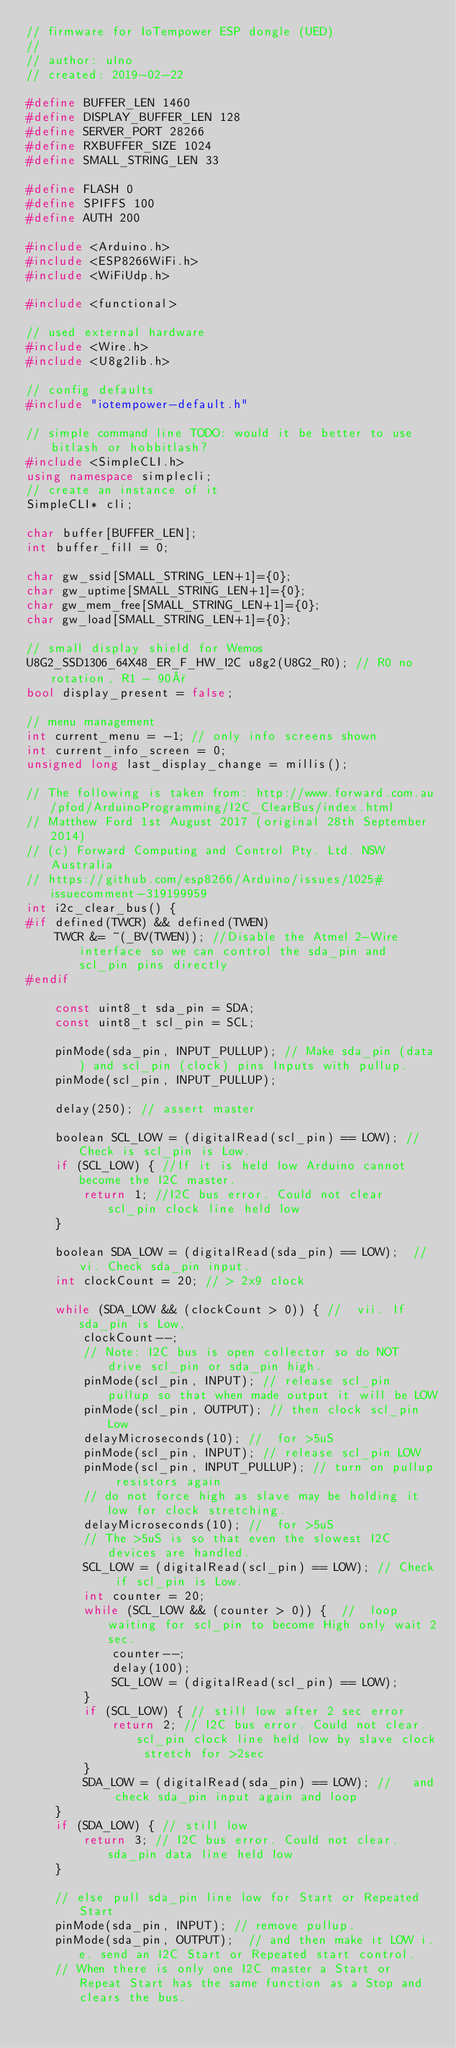<code> <loc_0><loc_0><loc_500><loc_500><_C++_>// firmware for IoTempower ESP dongle (UED)
//
// author: ulno
// created: 2019-02-22

#define BUFFER_LEN 1460
#define DISPLAY_BUFFER_LEN 128
#define SERVER_PORT 28266
#define RXBUFFER_SIZE 1024
#define SMALL_STRING_LEN 33

#define FLASH 0
#define SPIFFS 100
#define AUTH 200

#include <Arduino.h>
#include <ESP8266WiFi.h>
#include <WiFiUdp.h>

#include <functional>

// used external hardware
#include <Wire.h>
#include <U8g2lib.h>

// config defaults
#include "iotempower-default.h"

// simple command line TODO: would it be better to use bitlash or hobbitlash?
#include <SimpleCLI.h>
using namespace simplecli;
// create an instance of it
SimpleCLI* cli;

char buffer[BUFFER_LEN];
int buffer_fill = 0;

char gw_ssid[SMALL_STRING_LEN+1]={0};
char gw_uptime[SMALL_STRING_LEN+1]={0};
char gw_mem_free[SMALL_STRING_LEN+1]={0};
char gw_load[SMALL_STRING_LEN+1]={0};

// small display shield for Wemos
U8G2_SSD1306_64X48_ER_F_HW_I2C u8g2(U8G2_R0); // R0 no rotation, R1 - 90°
bool display_present = false;

// menu management
int current_menu = -1; // only info screens shown
int current_info_screen = 0;
unsigned long last_display_change = millis();

// The following is taken from: http://www.forward.com.au/pfod/ArduinoProgramming/I2C_ClearBus/index.html
// Matthew Ford 1st August 2017 (original 28th September 2014)
// (c) Forward Computing and Control Pty. Ltd. NSW Australia
// https://github.com/esp8266/Arduino/issues/1025#issuecomment-319199959
int i2c_clear_bus() {
#if defined(TWCR) && defined(TWEN)
    TWCR &= ~(_BV(TWEN)); //Disable the Atmel 2-Wire interface so we can control the sda_pin and scl_pin pins directly
#endif

    const uint8_t sda_pin = SDA;
    const uint8_t scl_pin = SCL;

    pinMode(sda_pin, INPUT_PULLUP); // Make sda_pin (data) and scl_pin (clock) pins Inputs with pullup.
    pinMode(scl_pin, INPUT_PULLUP);

    delay(250); // assert master

    boolean SCL_LOW = (digitalRead(scl_pin) == LOW); // Check is scl_pin is Low.
    if (SCL_LOW) { //If it is held low Arduino cannot become the I2C master. 
        return 1; //I2C bus error. Could not clear scl_pin clock line held low
    }

    boolean SDA_LOW = (digitalRead(sda_pin) == LOW);  // vi. Check sda_pin input.
    int clockCount = 20; // > 2x9 clock

    while (SDA_LOW && (clockCount > 0)) { //  vii. If sda_pin is Low,
        clockCount--;
        // Note: I2C bus is open collector so do NOT drive scl_pin or sda_pin high.
        pinMode(scl_pin, INPUT); // release scl_pin pullup so that when made output it will be LOW
        pinMode(scl_pin, OUTPUT); // then clock scl_pin Low
        delayMicroseconds(10); //  for >5uS
        pinMode(scl_pin, INPUT); // release scl_pin LOW
        pinMode(scl_pin, INPUT_PULLUP); // turn on pullup resistors again
        // do not force high as slave may be holding it low for clock stretching.
        delayMicroseconds(10); //  for >5uS
        // The >5uS is so that even the slowest I2C devices are handled.
        SCL_LOW = (digitalRead(scl_pin) == LOW); // Check if scl_pin is Low.
        int counter = 20;
        while (SCL_LOW && (counter > 0)) {  //  loop waiting for scl_pin to become High only wait 2sec.
            counter--;
            delay(100);
            SCL_LOW = (digitalRead(scl_pin) == LOW);
        }
        if (SCL_LOW) { // still low after 2 sec error
            return 2; // I2C bus error. Could not clear. scl_pin clock line held low by slave clock stretch for >2sec
        }
        SDA_LOW = (digitalRead(sda_pin) == LOW); //   and check sda_pin input again and loop
    }
    if (SDA_LOW) { // still low
        return 3; // I2C bus error. Could not clear. sda_pin data line held low
    }

    // else pull sda_pin line low for Start or Repeated Start
    pinMode(sda_pin, INPUT); // remove pullup.
    pinMode(sda_pin, OUTPUT);  // and then make it LOW i.e. send an I2C Start or Repeated start control.
    // When there is only one I2C master a Start or Repeat Start has the same function as a Stop and clears the bus.</code> 